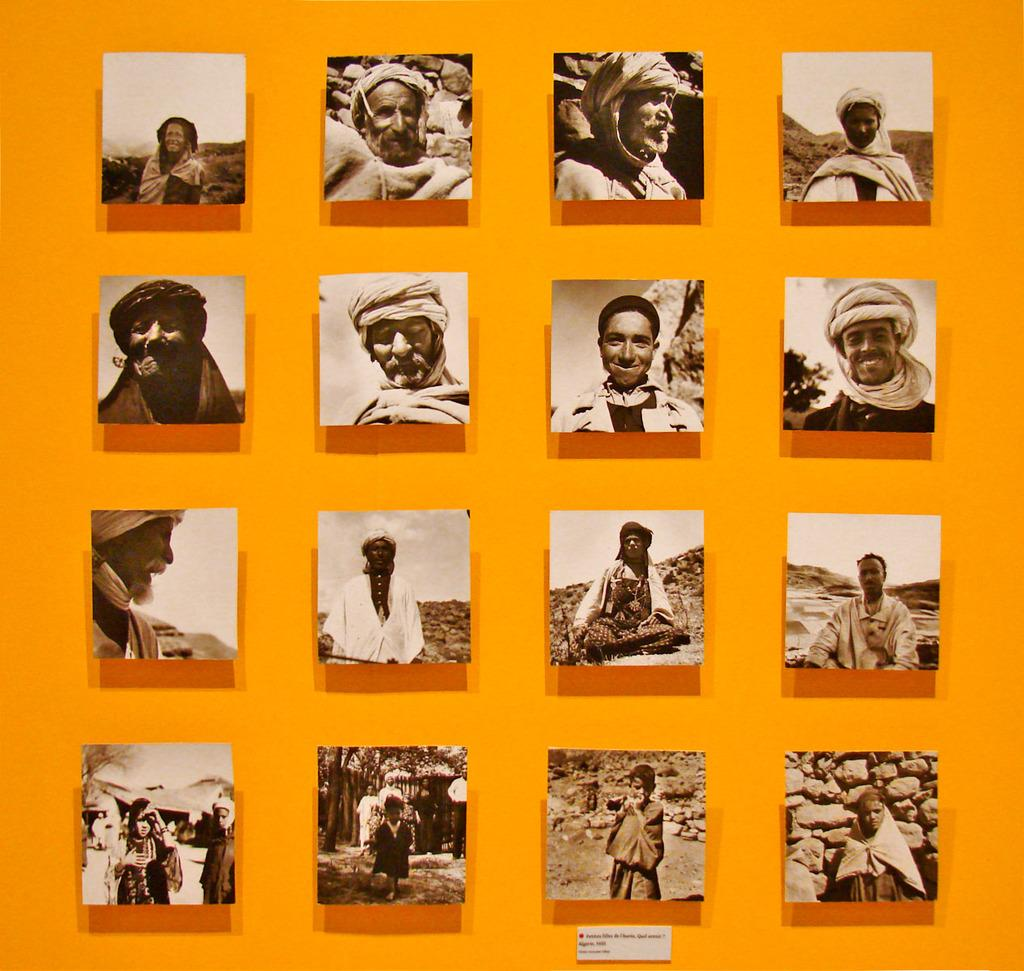What type of environment is depicted in the image? The image is set in a college environment. Can you describe the people in the image? Unfortunately, the provided facts do not give any specific details about the people in the image. What type of building is the father standing in front of in the image? There is no father or building present in the image, as the provided facts only mention a college environment and people. 